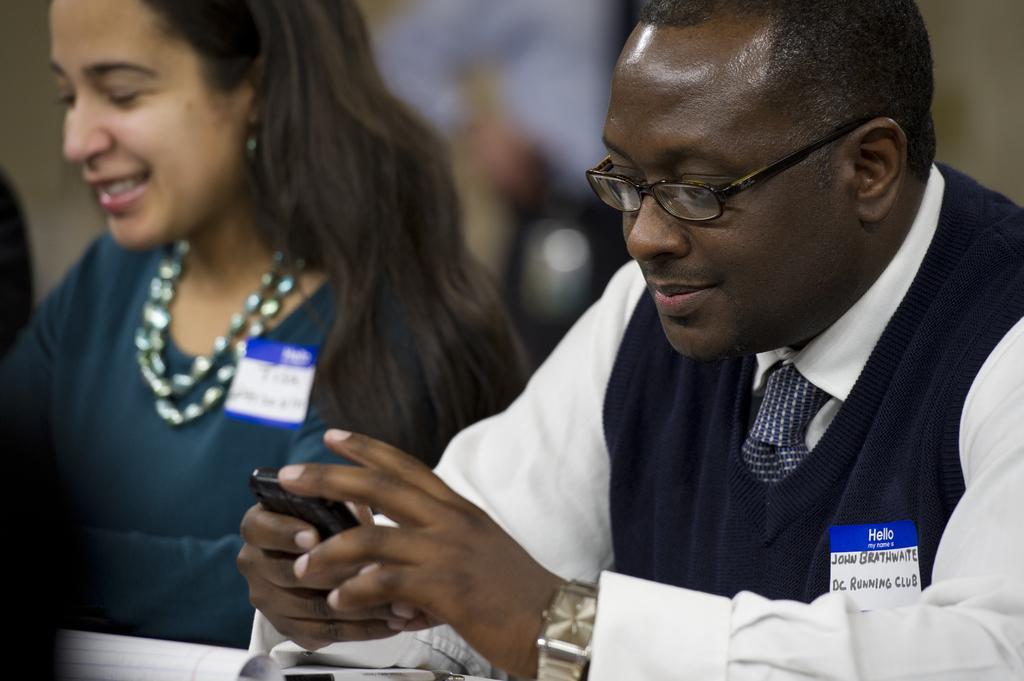How would you summarize this image in a sentence or two? This picture is taken inside the room. In this image, on the right side, we can see a man holding a mobile in his hand. On the left side, we can also see a woman. 